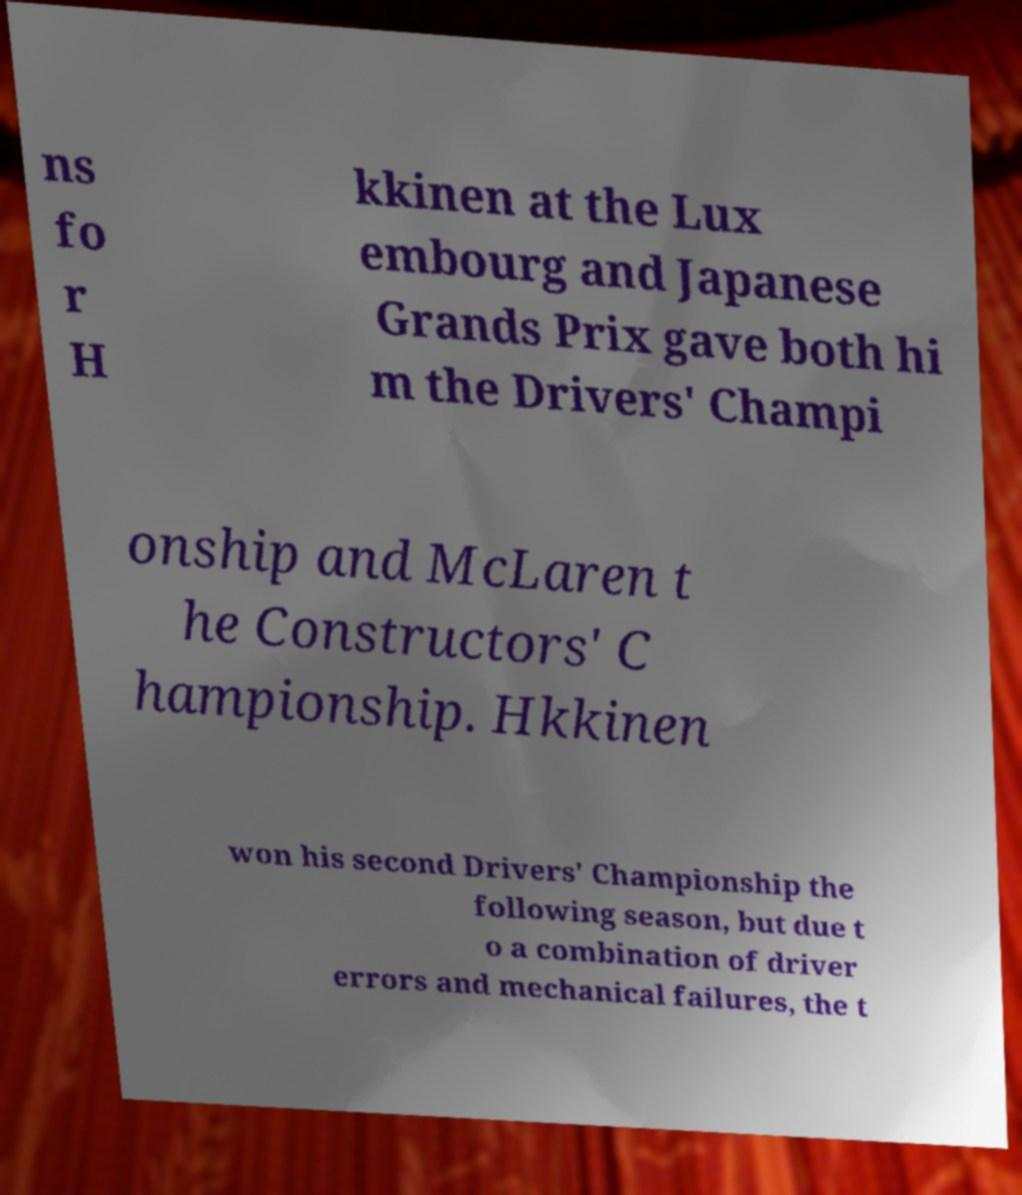Please identify and transcribe the text found in this image. ns fo r H kkinen at the Lux embourg and Japanese Grands Prix gave both hi m the Drivers' Champi onship and McLaren t he Constructors' C hampionship. Hkkinen won his second Drivers' Championship the following season, but due t o a combination of driver errors and mechanical failures, the t 